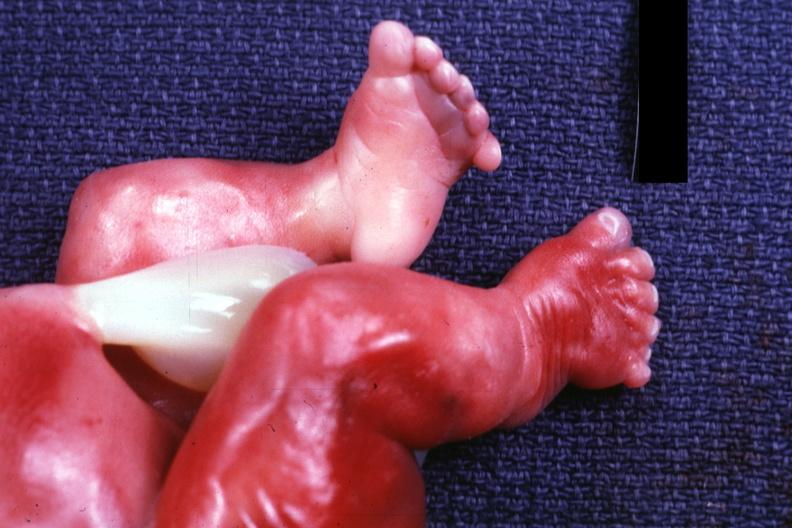do sets appear clubbed?
Answer the question using a single word or phrase. No 